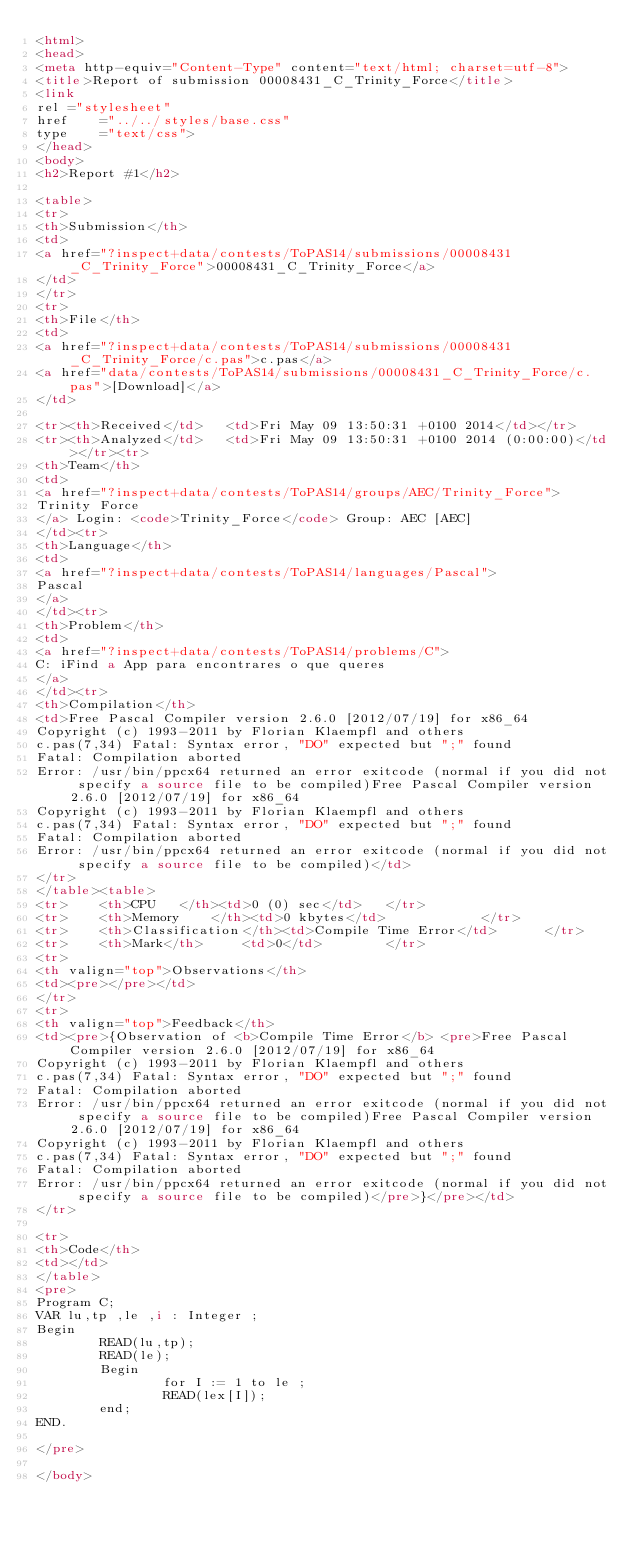<code> <loc_0><loc_0><loc_500><loc_500><_HTML_><html>
<head>
<meta http-equiv="Content-Type" content="text/html; charset=utf-8">
<title>Report of submission 00008431_C_Trinity_Force</title>
<link
rel	="stylesheet"
href	="../../styles/base.css"
type	="text/css">
</head>
<body>
<h2>Report #1</h2>

<table>
<tr>
<th>Submission</th>
<td>
<a href="?inspect+data/contests/ToPAS14/submissions/00008431_C_Trinity_Force">00008431_C_Trinity_Force</a>
</td>
</tr>
<tr>
<th>File</th>
<td>
<a href="?inspect+data/contests/ToPAS14/submissions/00008431_C_Trinity_Force/c.pas">c.pas</a>
<a href="data/contests/ToPAS14/submissions/00008431_C_Trinity_Force/c.pas">[Download]</a>
</td>

<tr><th>Received</td>	<td>Fri May 09 13:50:31 +0100 2014</td></tr>
<tr><th>Analyzed</td>	<td>Fri May 09 13:50:31 +0100 2014 (0:00:00)</td></tr><tr>
<th>Team</th>
<td>
<a href="?inspect+data/contests/ToPAS14/groups/AEC/Trinity_Force">
Trinity Force
</a> Login: <code>Trinity_Force</code> Group: AEC [AEC]
</td><tr>
<th>Language</th>
<td>
<a href="?inspect+data/contests/ToPAS14/languages/Pascal">
Pascal
</a>
</td><tr>
<th>Problem</th>
<td>
<a href="?inspect+data/contests/ToPAS14/problems/C">
C: iFind a App para encontrares o que queres
</a>
</td><tr>
<th>Compilation</th>
<td>Free Pascal Compiler version 2.6.0 [2012/07/19] for x86_64
Copyright (c) 1993-2011 by Florian Klaempfl and others
c.pas(7,34) Fatal: Syntax error, "DO" expected but ";" found
Fatal: Compilation aborted
Error: /usr/bin/ppcx64 returned an error exitcode (normal if you did not specify a source file to be compiled)Free Pascal Compiler version 2.6.0 [2012/07/19] for x86_64
Copyright (c) 1993-2011 by Florian Klaempfl and others
c.pas(7,34) Fatal: Syntax error, "DO" expected but ";" found
Fatal: Compilation aborted
Error: /usr/bin/ppcx64 returned an error exitcode (normal if you did not specify a source file to be compiled)</td>
</tr>
</table><table>
<tr>	<th>CPU	  </th><td>0 (0) sec</td>	</tr>
<tr>	<th>Memory	  </th><td>0 kbytes</td>			</tr>
<tr>	<th>Classification</th><td>Compile Time Error</td>		</tr>
<tr>	<th>Mark</th>	  <td>0</td>		</tr>
<tr>
<th valign="top">Observations</th>
<td><pre></pre></td>
</tr>
<tr>
<th valign="top">Feedback</th>
<td><pre>{Observation of <b>Compile Time Error</b> <pre>Free Pascal Compiler version 2.6.0 [2012/07/19] for x86_64
Copyright (c) 1993-2011 by Florian Klaempfl and others
c.pas(7,34) Fatal: Syntax error, "DO" expected but ";" found
Fatal: Compilation aborted
Error: /usr/bin/ppcx64 returned an error exitcode (normal if you did not specify a source file to be compiled)Free Pascal Compiler version 2.6.0 [2012/07/19] for x86_64
Copyright (c) 1993-2011 by Florian Klaempfl and others
c.pas(7,34) Fatal: Syntax error, "DO" expected but ";" found
Fatal: Compilation aborted
Error: /usr/bin/ppcx64 returned an error exitcode (normal if you did not specify a source file to be compiled)</pre>}</pre></td>
</tr>

<tr>
<th>Code</th>
<td></td>
</table>
<pre>
Program C;
VAR lu,tp ,le ,i : Integer ;
Begin
        READ(lu,tp);
        READ(le);
        Begin
                for I := 1 to le ;
                READ(lex[I]);
        end;
END.

</pre>

</body></code> 